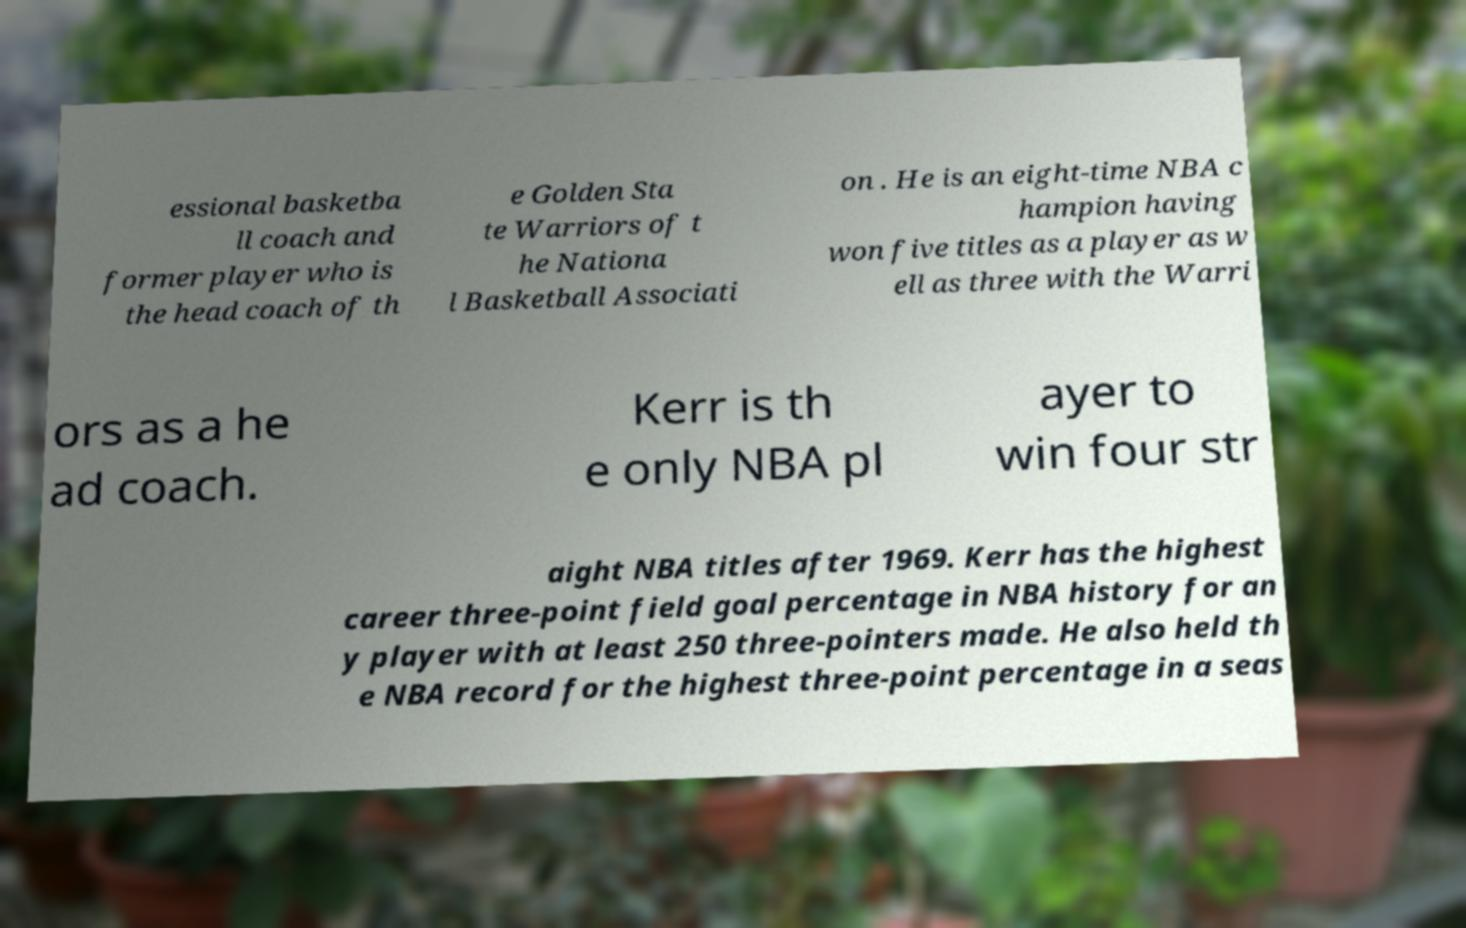Please identify and transcribe the text found in this image. essional basketba ll coach and former player who is the head coach of th e Golden Sta te Warriors of t he Nationa l Basketball Associati on . He is an eight-time NBA c hampion having won five titles as a player as w ell as three with the Warri ors as a he ad coach. Kerr is th e only NBA pl ayer to win four str aight NBA titles after 1969. Kerr has the highest career three-point field goal percentage in NBA history for an y player with at least 250 three-pointers made. He also held th e NBA record for the highest three-point percentage in a seas 